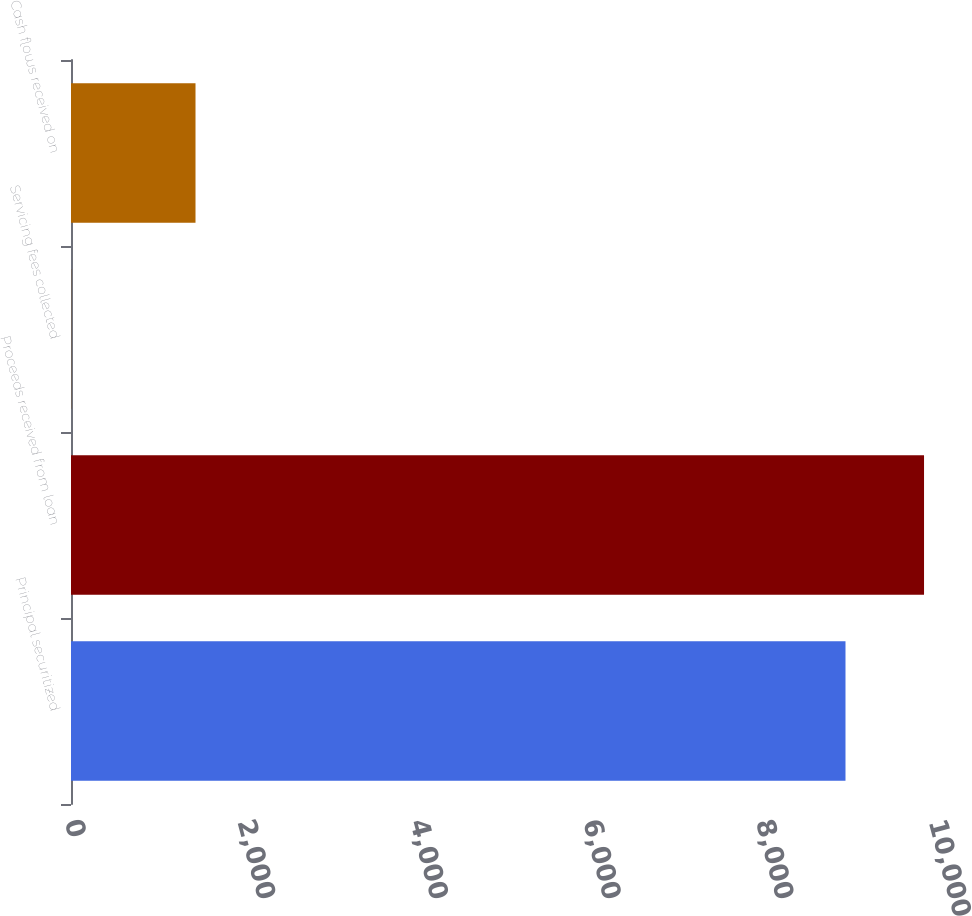Convert chart to OTSL. <chart><loc_0><loc_0><loc_500><loc_500><bar_chart><fcel>Principal securitized<fcel>Proceeds received from loan<fcel>Servicing fees collected<fcel>Cash flows received on<nl><fcel>8964<fcel>9873.1<fcel>3<fcel>1441<nl></chart> 